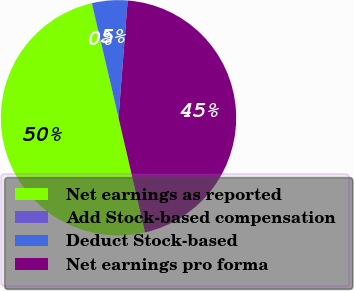Convert chart. <chart><loc_0><loc_0><loc_500><loc_500><pie_chart><fcel>Net earnings as reported<fcel>Add Stock-based compensation<fcel>Deduct Stock-based<fcel>Net earnings pro forma<nl><fcel>49.95%<fcel>0.05%<fcel>4.86%<fcel>45.14%<nl></chart> 